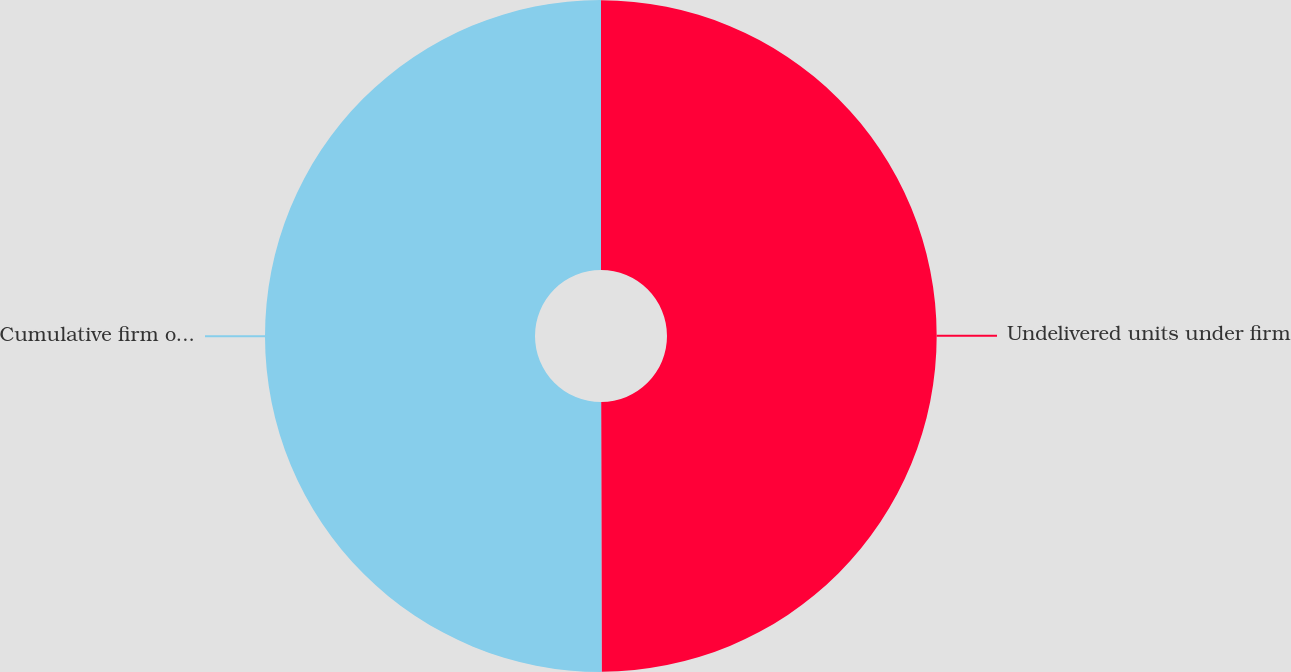Convert chart. <chart><loc_0><loc_0><loc_500><loc_500><pie_chart><fcel>Undelivered units under firm<fcel>Cumulative firm orders<nl><fcel>49.97%<fcel>50.03%<nl></chart> 